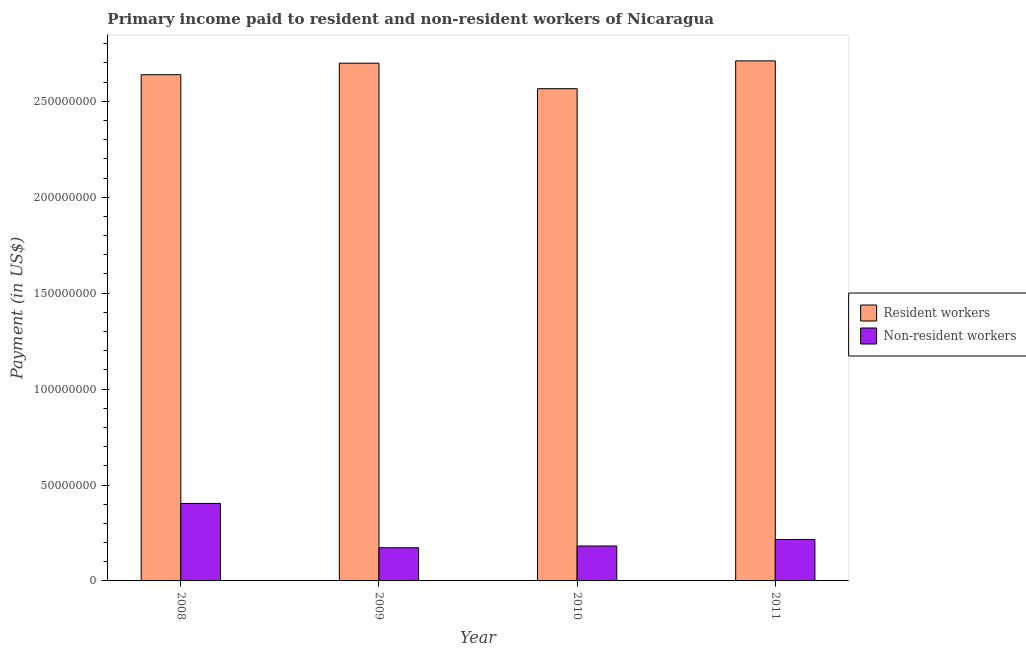How many groups of bars are there?
Your answer should be compact. 4. Are the number of bars per tick equal to the number of legend labels?
Your answer should be very brief. Yes. How many bars are there on the 3rd tick from the left?
Offer a terse response. 2. What is the label of the 4th group of bars from the left?
Your response must be concise. 2011. What is the payment made to non-resident workers in 2009?
Offer a very short reply. 1.73e+07. Across all years, what is the maximum payment made to resident workers?
Offer a very short reply. 2.71e+08. Across all years, what is the minimum payment made to non-resident workers?
Provide a succinct answer. 1.73e+07. In which year was the payment made to resident workers minimum?
Your response must be concise. 2010. What is the total payment made to non-resident workers in the graph?
Your answer should be very brief. 9.75e+07. What is the difference between the payment made to non-resident workers in 2009 and that in 2011?
Your answer should be compact. -4.30e+06. What is the difference between the payment made to resident workers in 2008 and the payment made to non-resident workers in 2009?
Make the answer very short. -6.00e+06. What is the average payment made to resident workers per year?
Keep it short and to the point. 2.65e+08. In the year 2008, what is the difference between the payment made to non-resident workers and payment made to resident workers?
Offer a very short reply. 0. In how many years, is the payment made to non-resident workers greater than 160000000 US$?
Give a very brief answer. 0. What is the ratio of the payment made to non-resident workers in 2010 to that in 2011?
Provide a short and direct response. 0.84. Is the payment made to resident workers in 2009 less than that in 2010?
Offer a very short reply. No. What is the difference between the highest and the second highest payment made to non-resident workers?
Provide a short and direct response. 1.88e+07. What is the difference between the highest and the lowest payment made to resident workers?
Keep it short and to the point. 1.45e+07. In how many years, is the payment made to resident workers greater than the average payment made to resident workers taken over all years?
Keep it short and to the point. 2. Is the sum of the payment made to resident workers in 2010 and 2011 greater than the maximum payment made to non-resident workers across all years?
Your answer should be compact. Yes. What does the 1st bar from the left in 2008 represents?
Your answer should be very brief. Resident workers. What does the 2nd bar from the right in 2008 represents?
Provide a succinct answer. Resident workers. How many years are there in the graph?
Make the answer very short. 4. Does the graph contain grids?
Keep it short and to the point. No. Where does the legend appear in the graph?
Make the answer very short. Center right. How many legend labels are there?
Offer a very short reply. 2. What is the title of the graph?
Ensure brevity in your answer.  Primary income paid to resident and non-resident workers of Nicaragua. What is the label or title of the X-axis?
Keep it short and to the point. Year. What is the label or title of the Y-axis?
Your answer should be very brief. Payment (in US$). What is the Payment (in US$) of Resident workers in 2008?
Give a very brief answer. 2.64e+08. What is the Payment (in US$) in Non-resident workers in 2008?
Your response must be concise. 4.04e+07. What is the Payment (in US$) in Resident workers in 2009?
Offer a very short reply. 2.70e+08. What is the Payment (in US$) of Non-resident workers in 2009?
Give a very brief answer. 1.73e+07. What is the Payment (in US$) of Resident workers in 2010?
Offer a terse response. 2.57e+08. What is the Payment (in US$) of Non-resident workers in 2010?
Keep it short and to the point. 1.82e+07. What is the Payment (in US$) in Resident workers in 2011?
Ensure brevity in your answer.  2.71e+08. What is the Payment (in US$) of Non-resident workers in 2011?
Offer a terse response. 2.16e+07. Across all years, what is the maximum Payment (in US$) in Resident workers?
Offer a terse response. 2.71e+08. Across all years, what is the maximum Payment (in US$) in Non-resident workers?
Make the answer very short. 4.04e+07. Across all years, what is the minimum Payment (in US$) of Resident workers?
Keep it short and to the point. 2.57e+08. Across all years, what is the minimum Payment (in US$) of Non-resident workers?
Offer a very short reply. 1.73e+07. What is the total Payment (in US$) in Resident workers in the graph?
Offer a terse response. 1.06e+09. What is the total Payment (in US$) of Non-resident workers in the graph?
Make the answer very short. 9.75e+07. What is the difference between the Payment (in US$) of Resident workers in 2008 and that in 2009?
Provide a succinct answer. -6.00e+06. What is the difference between the Payment (in US$) of Non-resident workers in 2008 and that in 2009?
Ensure brevity in your answer.  2.31e+07. What is the difference between the Payment (in US$) of Resident workers in 2008 and that in 2010?
Provide a succinct answer. 7.30e+06. What is the difference between the Payment (in US$) in Non-resident workers in 2008 and that in 2010?
Make the answer very short. 2.22e+07. What is the difference between the Payment (in US$) of Resident workers in 2008 and that in 2011?
Your response must be concise. -7.20e+06. What is the difference between the Payment (in US$) in Non-resident workers in 2008 and that in 2011?
Ensure brevity in your answer.  1.88e+07. What is the difference between the Payment (in US$) in Resident workers in 2009 and that in 2010?
Make the answer very short. 1.33e+07. What is the difference between the Payment (in US$) of Non-resident workers in 2009 and that in 2010?
Provide a short and direct response. -9.00e+05. What is the difference between the Payment (in US$) in Resident workers in 2009 and that in 2011?
Your response must be concise. -1.20e+06. What is the difference between the Payment (in US$) of Non-resident workers in 2009 and that in 2011?
Give a very brief answer. -4.30e+06. What is the difference between the Payment (in US$) of Resident workers in 2010 and that in 2011?
Your answer should be very brief. -1.45e+07. What is the difference between the Payment (in US$) in Non-resident workers in 2010 and that in 2011?
Make the answer very short. -3.40e+06. What is the difference between the Payment (in US$) of Resident workers in 2008 and the Payment (in US$) of Non-resident workers in 2009?
Provide a succinct answer. 2.47e+08. What is the difference between the Payment (in US$) in Resident workers in 2008 and the Payment (in US$) in Non-resident workers in 2010?
Ensure brevity in your answer.  2.46e+08. What is the difference between the Payment (in US$) of Resident workers in 2008 and the Payment (in US$) of Non-resident workers in 2011?
Offer a very short reply. 2.42e+08. What is the difference between the Payment (in US$) of Resident workers in 2009 and the Payment (in US$) of Non-resident workers in 2010?
Ensure brevity in your answer.  2.52e+08. What is the difference between the Payment (in US$) of Resident workers in 2009 and the Payment (in US$) of Non-resident workers in 2011?
Provide a succinct answer. 2.48e+08. What is the difference between the Payment (in US$) in Resident workers in 2010 and the Payment (in US$) in Non-resident workers in 2011?
Make the answer very short. 2.35e+08. What is the average Payment (in US$) in Resident workers per year?
Your response must be concise. 2.65e+08. What is the average Payment (in US$) in Non-resident workers per year?
Offer a terse response. 2.44e+07. In the year 2008, what is the difference between the Payment (in US$) of Resident workers and Payment (in US$) of Non-resident workers?
Provide a short and direct response. 2.24e+08. In the year 2009, what is the difference between the Payment (in US$) in Resident workers and Payment (in US$) in Non-resident workers?
Offer a terse response. 2.53e+08. In the year 2010, what is the difference between the Payment (in US$) in Resident workers and Payment (in US$) in Non-resident workers?
Make the answer very short. 2.38e+08. In the year 2011, what is the difference between the Payment (in US$) in Resident workers and Payment (in US$) in Non-resident workers?
Ensure brevity in your answer.  2.50e+08. What is the ratio of the Payment (in US$) of Resident workers in 2008 to that in 2009?
Ensure brevity in your answer.  0.98. What is the ratio of the Payment (in US$) in Non-resident workers in 2008 to that in 2009?
Your answer should be compact. 2.34. What is the ratio of the Payment (in US$) of Resident workers in 2008 to that in 2010?
Keep it short and to the point. 1.03. What is the ratio of the Payment (in US$) in Non-resident workers in 2008 to that in 2010?
Make the answer very short. 2.22. What is the ratio of the Payment (in US$) of Resident workers in 2008 to that in 2011?
Your response must be concise. 0.97. What is the ratio of the Payment (in US$) in Non-resident workers in 2008 to that in 2011?
Your answer should be compact. 1.87. What is the ratio of the Payment (in US$) in Resident workers in 2009 to that in 2010?
Give a very brief answer. 1.05. What is the ratio of the Payment (in US$) in Non-resident workers in 2009 to that in 2010?
Ensure brevity in your answer.  0.95. What is the ratio of the Payment (in US$) in Non-resident workers in 2009 to that in 2011?
Make the answer very short. 0.8. What is the ratio of the Payment (in US$) in Resident workers in 2010 to that in 2011?
Your answer should be compact. 0.95. What is the ratio of the Payment (in US$) of Non-resident workers in 2010 to that in 2011?
Provide a short and direct response. 0.84. What is the difference between the highest and the second highest Payment (in US$) in Resident workers?
Keep it short and to the point. 1.20e+06. What is the difference between the highest and the second highest Payment (in US$) in Non-resident workers?
Provide a short and direct response. 1.88e+07. What is the difference between the highest and the lowest Payment (in US$) of Resident workers?
Keep it short and to the point. 1.45e+07. What is the difference between the highest and the lowest Payment (in US$) of Non-resident workers?
Give a very brief answer. 2.31e+07. 